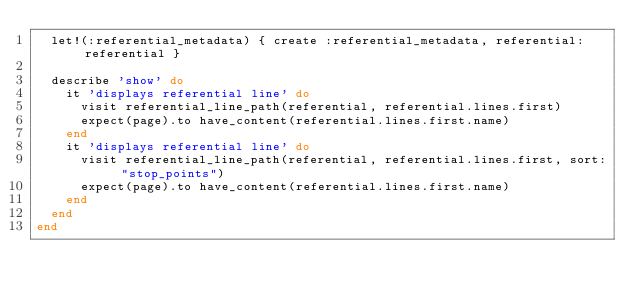<code> <loc_0><loc_0><loc_500><loc_500><_Ruby_>  let!(:referential_metadata) { create :referential_metadata, referential: referential }

  describe 'show' do
    it 'displays referential line' do
      visit referential_line_path(referential, referential.lines.first)
      expect(page).to have_content(referential.lines.first.name)
    end
    it 'displays referential line' do
      visit referential_line_path(referential, referential.lines.first, sort: "stop_points")
      expect(page).to have_content(referential.lines.first.name)
    end
  end
end
</code> 